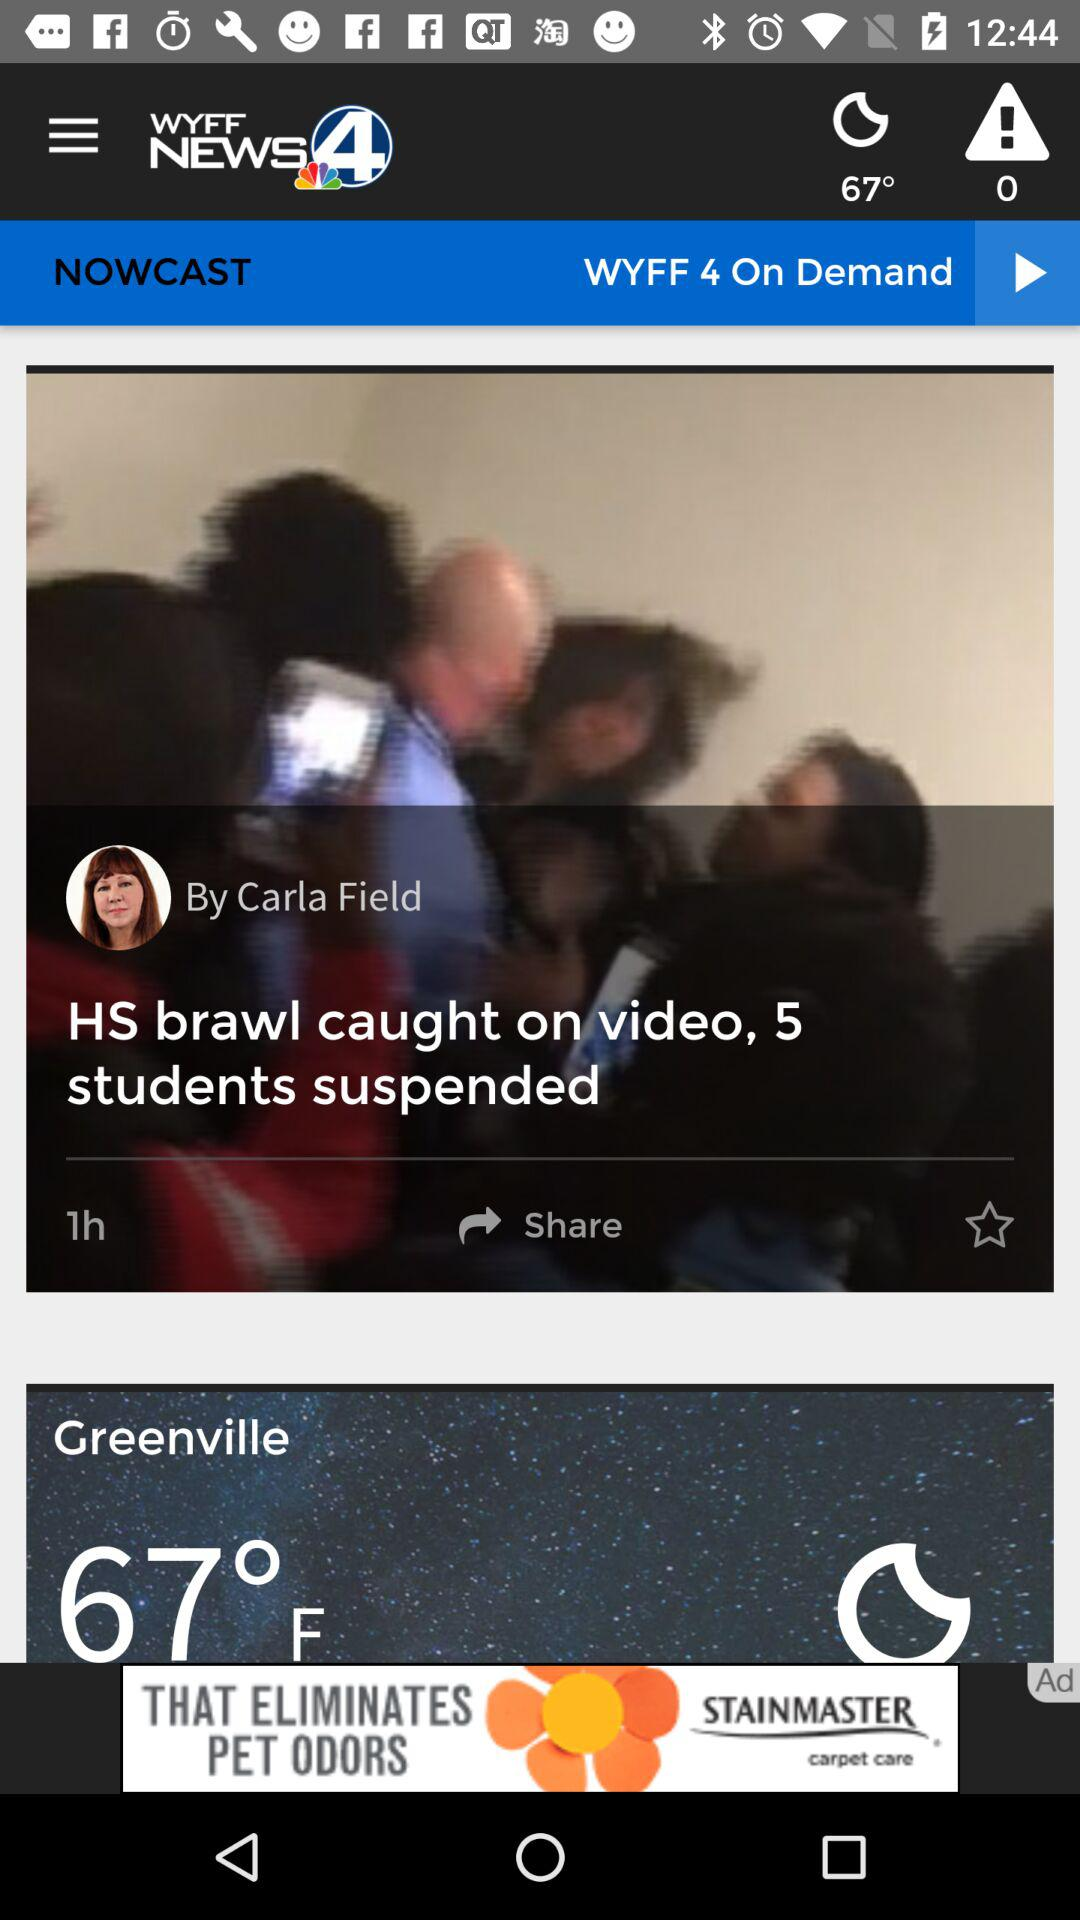What is the temperature? The temperature is 67 degrees Fahrenheit. 